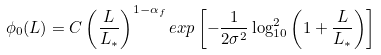Convert formula to latex. <formula><loc_0><loc_0><loc_500><loc_500>\phi _ { 0 } ( L ) = C \left ( \frac { L } { L _ { * } } \right ) ^ { 1 - \alpha _ { f } } e x p \left [ - \frac { 1 } { 2 \sigma ^ { 2 } } \log ^ { 2 } _ { 1 0 } \left ( 1 + \frac { L } { L _ { * } } \right ) \right ] \\</formula> 